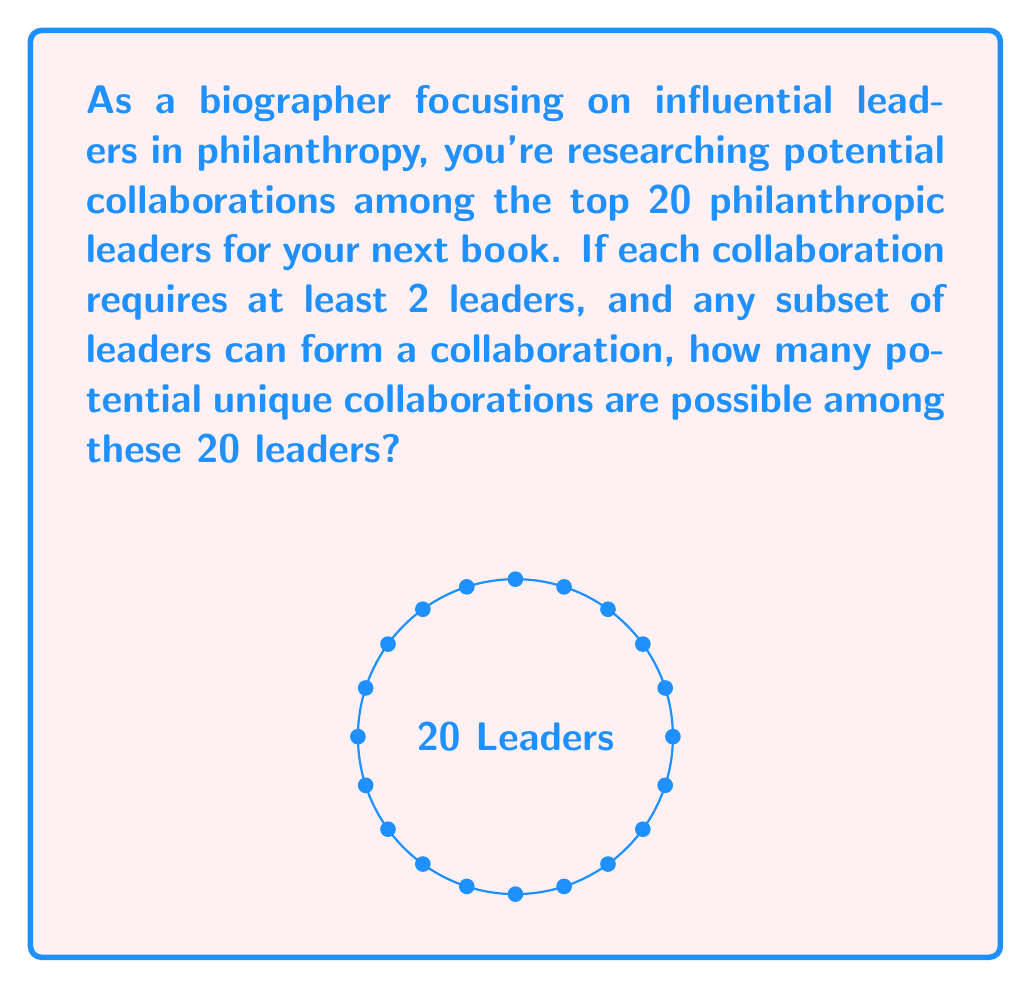Can you solve this math problem? To solve this problem, we need to use the concept of combinations from combinatorics. Here's a step-by-step explanation:

1) We're looking for all possible subsets of the 20 leaders, excluding the empty set (as a collaboration needs at least 2 leaders).

2) The number of ways to choose $k$ leaders from 20 is given by the combination formula:

   $${20 \choose k} = \frac{20!}{k!(20-k)!}$$

3) We need to sum this for all values of $k$ from 2 to 20:

   $$\sum_{k=2}^{20} {20 \choose k}$$

4) This sum is equal to the total number of subsets minus the subsets with 0 or 1 leader:

   $$2^{20} - {20 \choose 0} - {20 \choose 1}$$

5) We know that ${20 \choose 0} = 1$ and ${20 \choose 1} = 20$

6) Therefore, the total number of potential collaborations is:

   $$2^{20} - 1 - 20 = 1,048,576 - 21 = 1,048,555$$

Thus, there are 1,048,555 potential unique collaborations among the 20 philanthropic leaders.
Answer: 1,048,555 